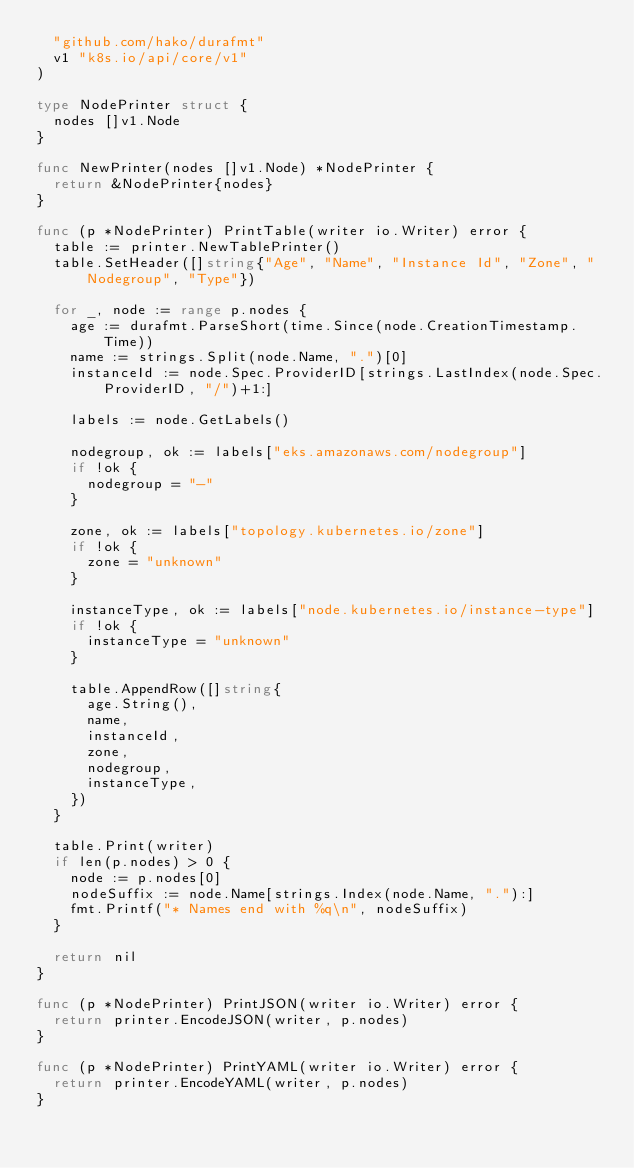Convert code to text. <code><loc_0><loc_0><loc_500><loc_500><_Go_>	"github.com/hako/durafmt"
	v1 "k8s.io/api/core/v1"
)

type NodePrinter struct {
	nodes []v1.Node
}

func NewPrinter(nodes []v1.Node) *NodePrinter {
	return &NodePrinter{nodes}
}

func (p *NodePrinter) PrintTable(writer io.Writer) error {
	table := printer.NewTablePrinter()
	table.SetHeader([]string{"Age", "Name", "Instance Id", "Zone", "Nodegroup", "Type"})

	for _, node := range p.nodes {
		age := durafmt.ParseShort(time.Since(node.CreationTimestamp.Time))
		name := strings.Split(node.Name, ".")[0]
		instanceId := node.Spec.ProviderID[strings.LastIndex(node.Spec.ProviderID, "/")+1:]

		labels := node.GetLabels()

		nodegroup, ok := labels["eks.amazonaws.com/nodegroup"]
		if !ok {
			nodegroup = "-"
		}

		zone, ok := labels["topology.kubernetes.io/zone"]
		if !ok {
			zone = "unknown"
		}

		instanceType, ok := labels["node.kubernetes.io/instance-type"]
		if !ok {
			instanceType = "unknown"
		}

		table.AppendRow([]string{
			age.String(),
			name,
			instanceId,
			zone,
			nodegroup,
			instanceType,
		})
	}

	table.Print(writer)
	if len(p.nodes) > 0 {
		node := p.nodes[0]
		nodeSuffix := node.Name[strings.Index(node.Name, "."):]
		fmt.Printf("* Names end with %q\n", nodeSuffix)
	}

	return nil
}

func (p *NodePrinter) PrintJSON(writer io.Writer) error {
	return printer.EncodeJSON(writer, p.nodes)
}

func (p *NodePrinter) PrintYAML(writer io.Writer) error {
	return printer.EncodeYAML(writer, p.nodes)
}
</code> 